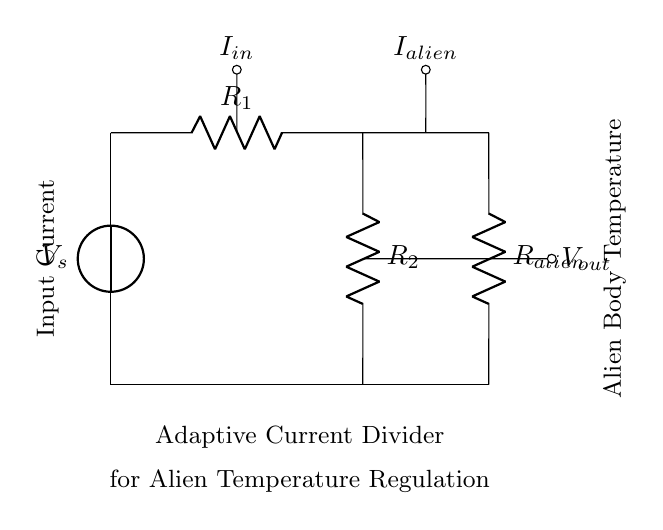What is the source voltage in this circuit? The source voltage is labeled as V_s in the diagram, representing the input voltage supplied to the circuit.
Answer: V_s What does R_1 represent in the circuit? R_1 is labeled as a resistor in the diagram, which is part of the adaptive current divider circuit and helps in controlling the current flow.
Answer: A resistor What is the function of R_alien in this circuit? R_alien is a resistor specifically designed for the alien's current, which regulates the temperature by affecting the current through it based on the voltage division.
Answer: Temperature regulation If the total input current is I_in, how would you determine the current I_alien? Using the current divider rule, I_alien can be calculated by the formula I_alien = I_in * (R_1 / (R_1 + R_2 + R_alien)), factoring in the resistances in the circuit.
Answer: By current divider rule What is the purpose of the adaptive current divider in this circuit? The adaptive current divider is designed to regulate the current flowing to R_alien, thus controlling the temperature of the alien body by adjusting the amount of current based on their specific needs.
Answer: Temperature regulation How many resistors are present in the circuit diagram? There are three resistors shown in the circuit: R_1, R_2, and R_alien, indicating multiple pathways for current distribution.
Answer: Three 